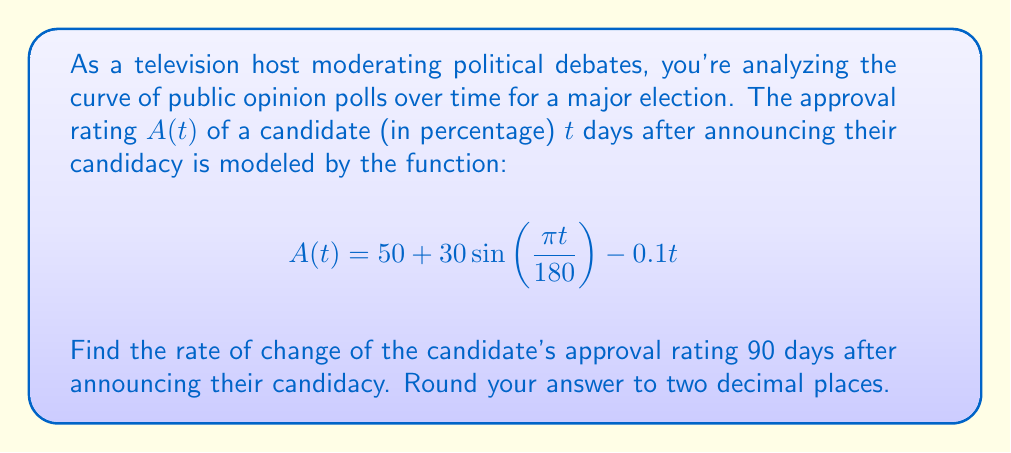Solve this math problem. To find the rate of change of the approval rating at $t = 90$ days, we need to calculate the derivative of $A(t)$ and evaluate it at $t = 90$.

Step 1: Calculate the derivative of $A(t)$
$$\frac{d}{dt}A(t) = \frac{d}{dt}\left(50 + 30\sin\left(\frac{\pi t}{180}\right) - 0.1t\right)$$

Using the chain rule for the sine term:
$$\frac{d}{dt}A(t) = 30 \cdot \frac{\pi}{180} \cos\left(\frac{\pi t}{180}\right) - 0.1$$

Step 2: Simplify the derivative
$$\frac{d}{dt}A(t) = \frac{\pi}{6} \cos\left(\frac{\pi t}{180}\right) - 0.1$$

Step 3: Evaluate the derivative at $t = 90$
$$\left.\frac{d}{dt}A(t)\right|_{t=90} = \frac{\pi}{6} \cos\left(\frac{\pi \cdot 90}{180}\right) - 0.1$$
$$= \frac{\pi}{6} \cos\left(\frac{\pi}{2}\right) - 0.1$$
$$= \frac{\pi}{6} \cdot 0 - 0.1$$
$$= -0.1$$

Step 4: Round to two decimal places
The rate of change at $t = 90$ is $-0.10$ percentage points per day.
Answer: $-0.10$ percentage points per day 